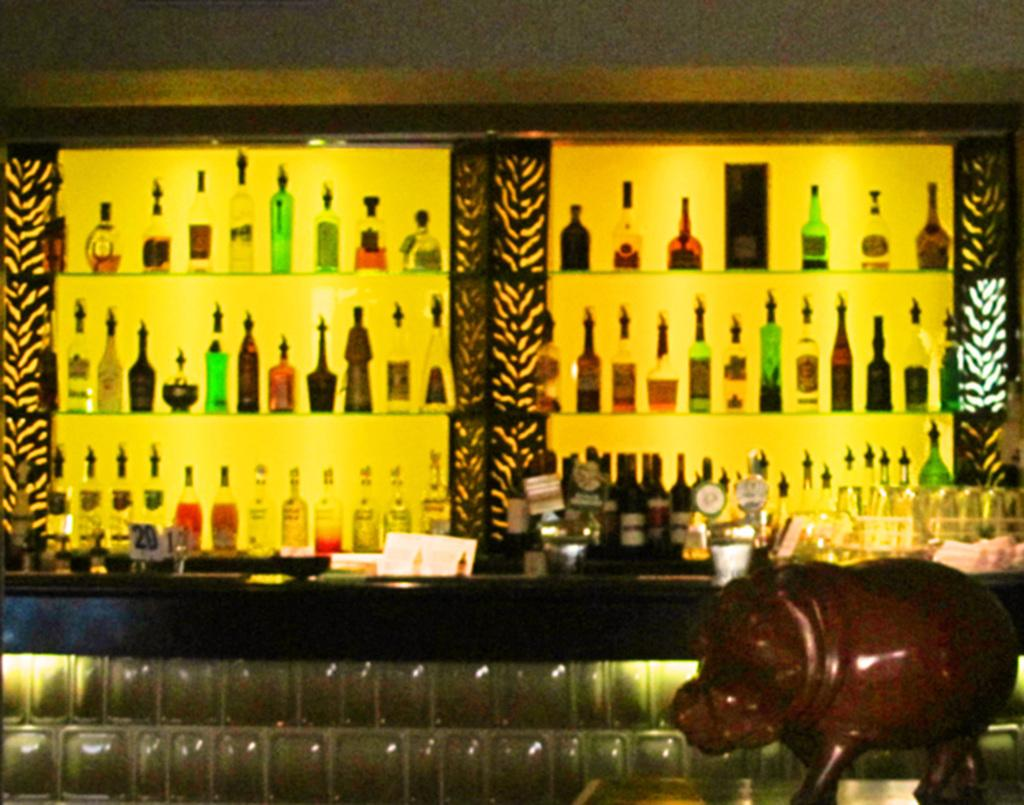What is the main subject of the image? The main subject of the image is a group of wine bottles. How are the wine bottles arranged in the image? The wine bottles are in a rack. Are there any other objects present in the image besides the wine bottles? Yes, there are some other objects in the image. Can you tell me how many gooses are standing on the wine bottles in the image? There are no gooses present in the image, and therefore no such activity can be observed. How does the pipe help maintain balance among the wine bottles in the image? There is no pipe present in the image, and the wine bottles are in a rack, not balancing on anything. 